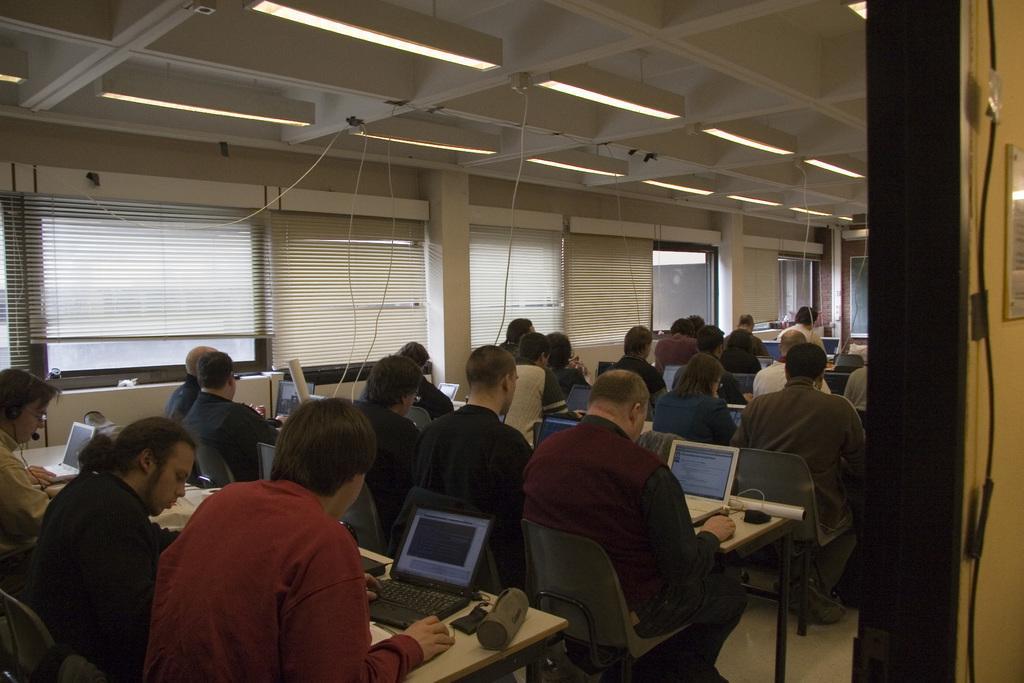Please provide a concise description of this image. In this image I see number of people who are sitting on the chairs and there are tables in front of them and there are laptops on it. In the background I see the windows. 